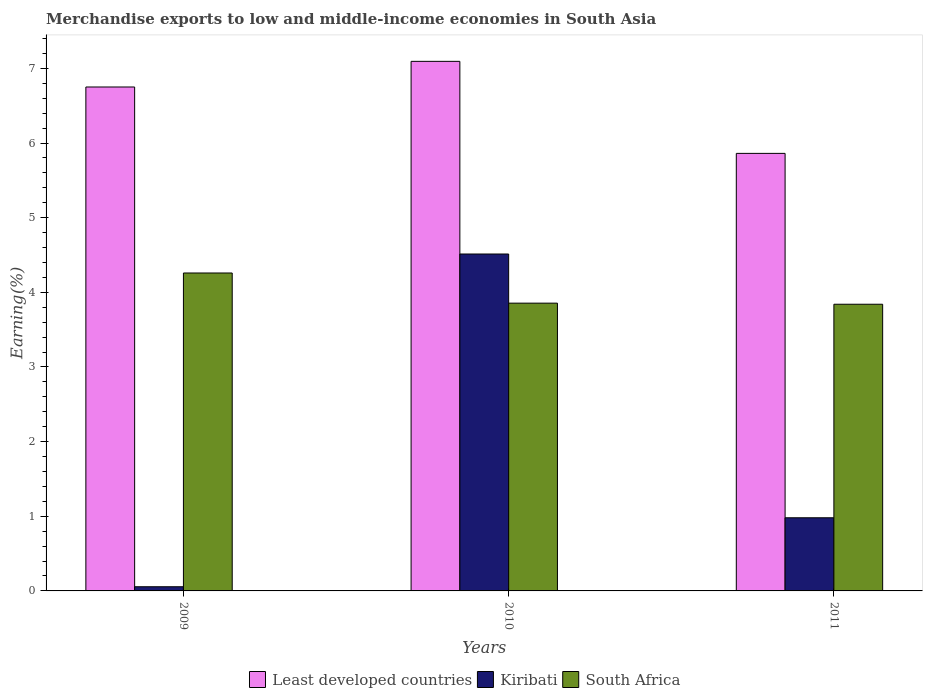How many different coloured bars are there?
Offer a very short reply. 3. Are the number of bars per tick equal to the number of legend labels?
Give a very brief answer. Yes. How many bars are there on the 2nd tick from the left?
Your response must be concise. 3. In how many cases, is the number of bars for a given year not equal to the number of legend labels?
Your response must be concise. 0. What is the percentage of amount earned from merchandise exports in South Africa in 2011?
Keep it short and to the point. 3.84. Across all years, what is the maximum percentage of amount earned from merchandise exports in South Africa?
Offer a terse response. 4.26. Across all years, what is the minimum percentage of amount earned from merchandise exports in Kiribati?
Provide a short and direct response. 0.06. In which year was the percentage of amount earned from merchandise exports in South Africa maximum?
Offer a terse response. 2009. In which year was the percentage of amount earned from merchandise exports in Kiribati minimum?
Your answer should be compact. 2009. What is the total percentage of amount earned from merchandise exports in Kiribati in the graph?
Provide a succinct answer. 5.55. What is the difference between the percentage of amount earned from merchandise exports in South Africa in 2009 and that in 2011?
Your answer should be compact. 0.42. What is the difference between the percentage of amount earned from merchandise exports in Kiribati in 2011 and the percentage of amount earned from merchandise exports in Least developed countries in 2010?
Your response must be concise. -6.11. What is the average percentage of amount earned from merchandise exports in Kiribati per year?
Make the answer very short. 1.85. In the year 2010, what is the difference between the percentage of amount earned from merchandise exports in South Africa and percentage of amount earned from merchandise exports in Kiribati?
Provide a succinct answer. -0.66. In how many years, is the percentage of amount earned from merchandise exports in South Africa greater than 4.4 %?
Your response must be concise. 0. What is the ratio of the percentage of amount earned from merchandise exports in South Africa in 2010 to that in 2011?
Offer a terse response. 1. What is the difference between the highest and the second highest percentage of amount earned from merchandise exports in Least developed countries?
Keep it short and to the point. 0.34. What is the difference between the highest and the lowest percentage of amount earned from merchandise exports in Kiribati?
Offer a terse response. 4.46. In how many years, is the percentage of amount earned from merchandise exports in Kiribati greater than the average percentage of amount earned from merchandise exports in Kiribati taken over all years?
Give a very brief answer. 1. What does the 1st bar from the left in 2009 represents?
Provide a short and direct response. Least developed countries. What does the 3rd bar from the right in 2009 represents?
Make the answer very short. Least developed countries. Is it the case that in every year, the sum of the percentage of amount earned from merchandise exports in South Africa and percentage of amount earned from merchandise exports in Least developed countries is greater than the percentage of amount earned from merchandise exports in Kiribati?
Give a very brief answer. Yes. Are the values on the major ticks of Y-axis written in scientific E-notation?
Offer a very short reply. No. Does the graph contain grids?
Make the answer very short. No. How many legend labels are there?
Make the answer very short. 3. How are the legend labels stacked?
Your answer should be compact. Horizontal. What is the title of the graph?
Ensure brevity in your answer.  Merchandise exports to low and middle-income economies in South Asia. Does "Korea (Republic)" appear as one of the legend labels in the graph?
Provide a short and direct response. No. What is the label or title of the Y-axis?
Offer a terse response. Earning(%). What is the Earning(%) of Least developed countries in 2009?
Provide a short and direct response. 6.75. What is the Earning(%) of Kiribati in 2009?
Offer a terse response. 0.06. What is the Earning(%) of South Africa in 2009?
Make the answer very short. 4.26. What is the Earning(%) in Least developed countries in 2010?
Offer a very short reply. 7.09. What is the Earning(%) of Kiribati in 2010?
Offer a very short reply. 4.51. What is the Earning(%) in South Africa in 2010?
Provide a succinct answer. 3.86. What is the Earning(%) in Least developed countries in 2011?
Provide a succinct answer. 5.86. What is the Earning(%) of Kiribati in 2011?
Your answer should be compact. 0.98. What is the Earning(%) in South Africa in 2011?
Your response must be concise. 3.84. Across all years, what is the maximum Earning(%) of Least developed countries?
Your answer should be very brief. 7.09. Across all years, what is the maximum Earning(%) of Kiribati?
Offer a very short reply. 4.51. Across all years, what is the maximum Earning(%) of South Africa?
Offer a very short reply. 4.26. Across all years, what is the minimum Earning(%) of Least developed countries?
Keep it short and to the point. 5.86. Across all years, what is the minimum Earning(%) in Kiribati?
Offer a very short reply. 0.06. Across all years, what is the minimum Earning(%) of South Africa?
Your answer should be very brief. 3.84. What is the total Earning(%) of Least developed countries in the graph?
Offer a terse response. 19.71. What is the total Earning(%) of Kiribati in the graph?
Offer a very short reply. 5.55. What is the total Earning(%) in South Africa in the graph?
Offer a very short reply. 11.95. What is the difference between the Earning(%) in Least developed countries in 2009 and that in 2010?
Offer a terse response. -0.34. What is the difference between the Earning(%) of Kiribati in 2009 and that in 2010?
Your answer should be compact. -4.46. What is the difference between the Earning(%) of South Africa in 2009 and that in 2010?
Offer a terse response. 0.4. What is the difference between the Earning(%) of Least developed countries in 2009 and that in 2011?
Ensure brevity in your answer.  0.89. What is the difference between the Earning(%) in Kiribati in 2009 and that in 2011?
Provide a succinct answer. -0.92. What is the difference between the Earning(%) of South Africa in 2009 and that in 2011?
Provide a short and direct response. 0.42. What is the difference between the Earning(%) of Least developed countries in 2010 and that in 2011?
Offer a terse response. 1.23. What is the difference between the Earning(%) in Kiribati in 2010 and that in 2011?
Your response must be concise. 3.53. What is the difference between the Earning(%) in South Africa in 2010 and that in 2011?
Provide a succinct answer. 0.01. What is the difference between the Earning(%) in Least developed countries in 2009 and the Earning(%) in Kiribati in 2010?
Your response must be concise. 2.24. What is the difference between the Earning(%) of Least developed countries in 2009 and the Earning(%) of South Africa in 2010?
Ensure brevity in your answer.  2.9. What is the difference between the Earning(%) in Kiribati in 2009 and the Earning(%) in South Africa in 2010?
Give a very brief answer. -3.8. What is the difference between the Earning(%) in Least developed countries in 2009 and the Earning(%) in Kiribati in 2011?
Offer a very short reply. 5.77. What is the difference between the Earning(%) of Least developed countries in 2009 and the Earning(%) of South Africa in 2011?
Offer a very short reply. 2.91. What is the difference between the Earning(%) in Kiribati in 2009 and the Earning(%) in South Africa in 2011?
Your response must be concise. -3.78. What is the difference between the Earning(%) in Least developed countries in 2010 and the Earning(%) in Kiribati in 2011?
Your response must be concise. 6.11. What is the difference between the Earning(%) of Least developed countries in 2010 and the Earning(%) of South Africa in 2011?
Give a very brief answer. 3.25. What is the difference between the Earning(%) in Kiribati in 2010 and the Earning(%) in South Africa in 2011?
Provide a succinct answer. 0.67. What is the average Earning(%) in Least developed countries per year?
Your response must be concise. 6.57. What is the average Earning(%) in Kiribati per year?
Make the answer very short. 1.85. What is the average Earning(%) of South Africa per year?
Offer a very short reply. 3.98. In the year 2009, what is the difference between the Earning(%) of Least developed countries and Earning(%) of Kiribati?
Keep it short and to the point. 6.69. In the year 2009, what is the difference between the Earning(%) in Least developed countries and Earning(%) in South Africa?
Your answer should be compact. 2.49. In the year 2009, what is the difference between the Earning(%) of Kiribati and Earning(%) of South Africa?
Your answer should be very brief. -4.2. In the year 2010, what is the difference between the Earning(%) of Least developed countries and Earning(%) of Kiribati?
Keep it short and to the point. 2.58. In the year 2010, what is the difference between the Earning(%) of Least developed countries and Earning(%) of South Africa?
Give a very brief answer. 3.24. In the year 2010, what is the difference between the Earning(%) of Kiribati and Earning(%) of South Africa?
Keep it short and to the point. 0.66. In the year 2011, what is the difference between the Earning(%) of Least developed countries and Earning(%) of Kiribati?
Your answer should be compact. 4.88. In the year 2011, what is the difference between the Earning(%) of Least developed countries and Earning(%) of South Africa?
Provide a succinct answer. 2.02. In the year 2011, what is the difference between the Earning(%) of Kiribati and Earning(%) of South Africa?
Offer a terse response. -2.86. What is the ratio of the Earning(%) of Least developed countries in 2009 to that in 2010?
Ensure brevity in your answer.  0.95. What is the ratio of the Earning(%) of Kiribati in 2009 to that in 2010?
Provide a succinct answer. 0.01. What is the ratio of the Earning(%) of South Africa in 2009 to that in 2010?
Offer a terse response. 1.1. What is the ratio of the Earning(%) of Least developed countries in 2009 to that in 2011?
Make the answer very short. 1.15. What is the ratio of the Earning(%) of Kiribati in 2009 to that in 2011?
Provide a succinct answer. 0.06. What is the ratio of the Earning(%) in South Africa in 2009 to that in 2011?
Keep it short and to the point. 1.11. What is the ratio of the Earning(%) of Least developed countries in 2010 to that in 2011?
Provide a succinct answer. 1.21. What is the ratio of the Earning(%) in Kiribati in 2010 to that in 2011?
Offer a terse response. 4.61. What is the ratio of the Earning(%) in South Africa in 2010 to that in 2011?
Offer a terse response. 1. What is the difference between the highest and the second highest Earning(%) in Least developed countries?
Keep it short and to the point. 0.34. What is the difference between the highest and the second highest Earning(%) of Kiribati?
Provide a succinct answer. 3.53. What is the difference between the highest and the second highest Earning(%) in South Africa?
Provide a succinct answer. 0.4. What is the difference between the highest and the lowest Earning(%) of Least developed countries?
Give a very brief answer. 1.23. What is the difference between the highest and the lowest Earning(%) of Kiribati?
Provide a succinct answer. 4.46. What is the difference between the highest and the lowest Earning(%) of South Africa?
Provide a short and direct response. 0.42. 